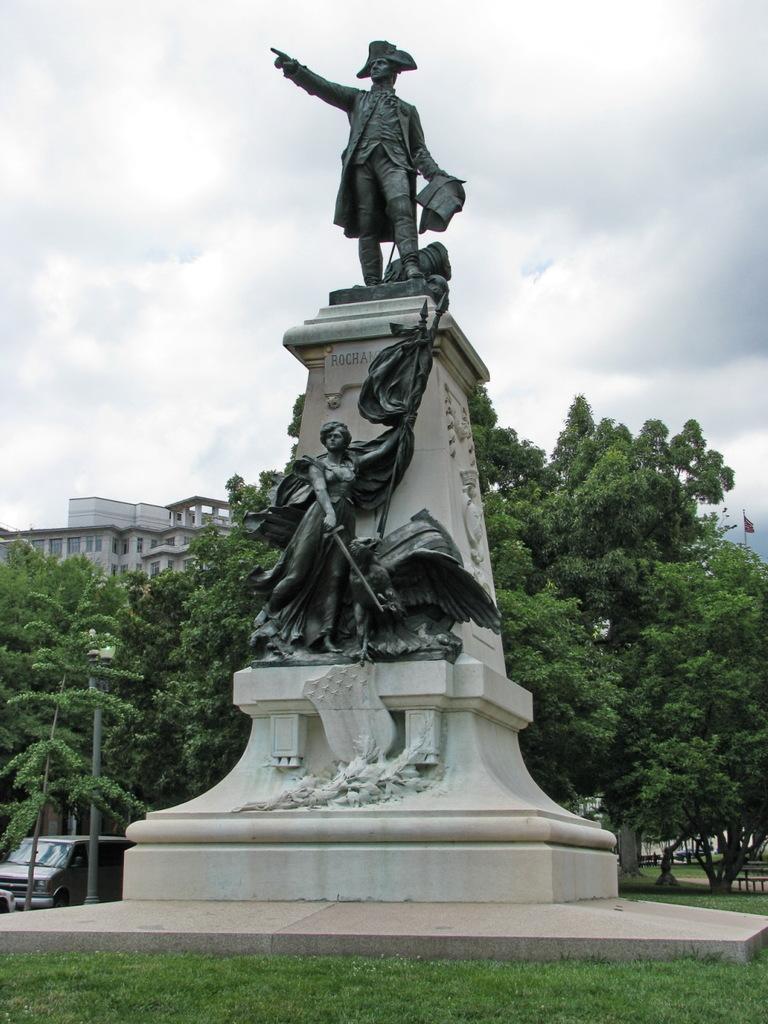Can you describe this image briefly? In the picture we can see some statues, there is grass and in the background of the picture are some trees, vehicles and there are some buildings and top of the picture there is cloudy sky. 